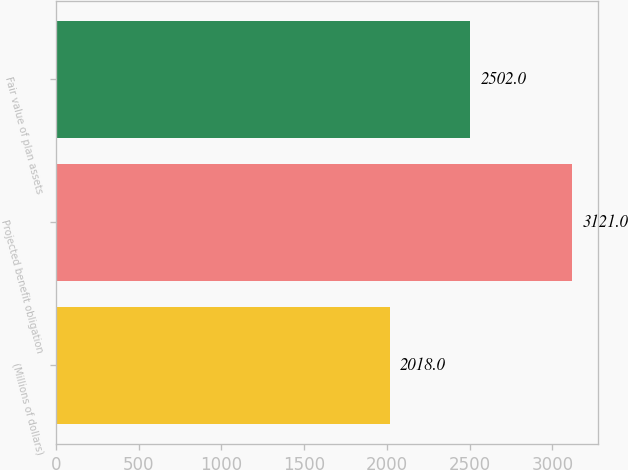<chart> <loc_0><loc_0><loc_500><loc_500><bar_chart><fcel>(Millions of dollars)<fcel>Projected benefit obligation<fcel>Fair value of plan assets<nl><fcel>2018<fcel>3121<fcel>2502<nl></chart> 